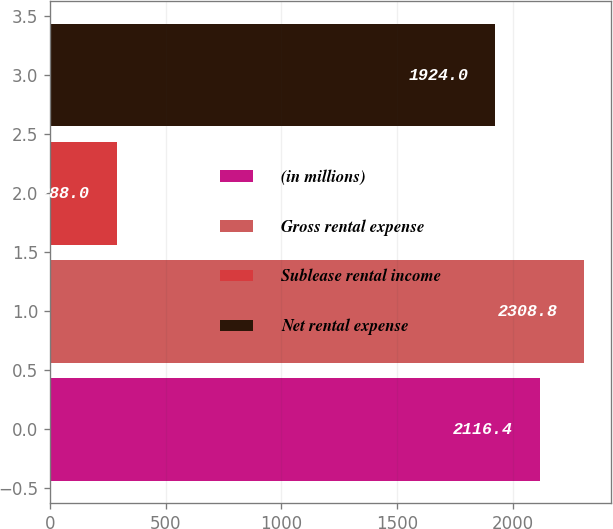Convert chart. <chart><loc_0><loc_0><loc_500><loc_500><bar_chart><fcel>(in millions)<fcel>Gross rental expense<fcel>Sublease rental income<fcel>Net rental expense<nl><fcel>2116.4<fcel>2308.8<fcel>288<fcel>1924<nl></chart> 